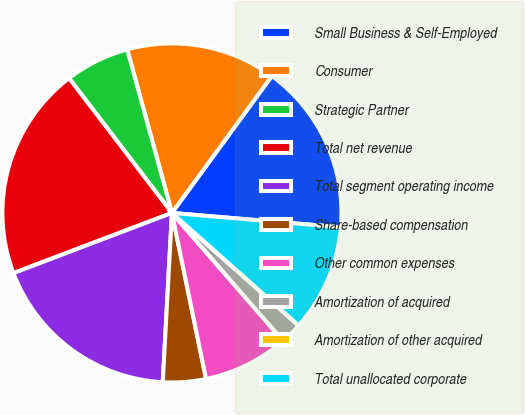Convert chart to OTSL. <chart><loc_0><loc_0><loc_500><loc_500><pie_chart><fcel>Small Business & Self-Employed<fcel>Consumer<fcel>Strategic Partner<fcel>Total net revenue<fcel>Total segment operating income<fcel>Share-based compensation<fcel>Other common expenses<fcel>Amortization of acquired<fcel>Amortization of other acquired<fcel>Total unallocated corporate<nl><fcel>16.32%<fcel>14.28%<fcel>6.13%<fcel>20.4%<fcel>18.36%<fcel>4.09%<fcel>8.16%<fcel>2.05%<fcel>0.01%<fcel>10.2%<nl></chart> 